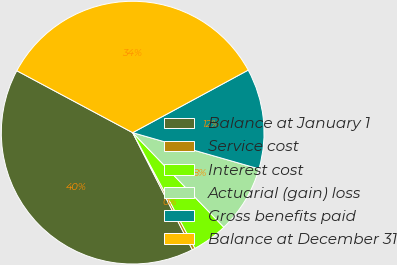Convert chart to OTSL. <chart><loc_0><loc_0><loc_500><loc_500><pie_chart><fcel>Balance at January 1<fcel>Service cost<fcel>Interest cost<fcel>Actuarial (gain) loss<fcel>Gross benefits paid<fcel>Balance at December 31<nl><fcel>40.31%<fcel>0.36%<fcel>4.35%<fcel>8.35%<fcel>12.34%<fcel>34.29%<nl></chart> 